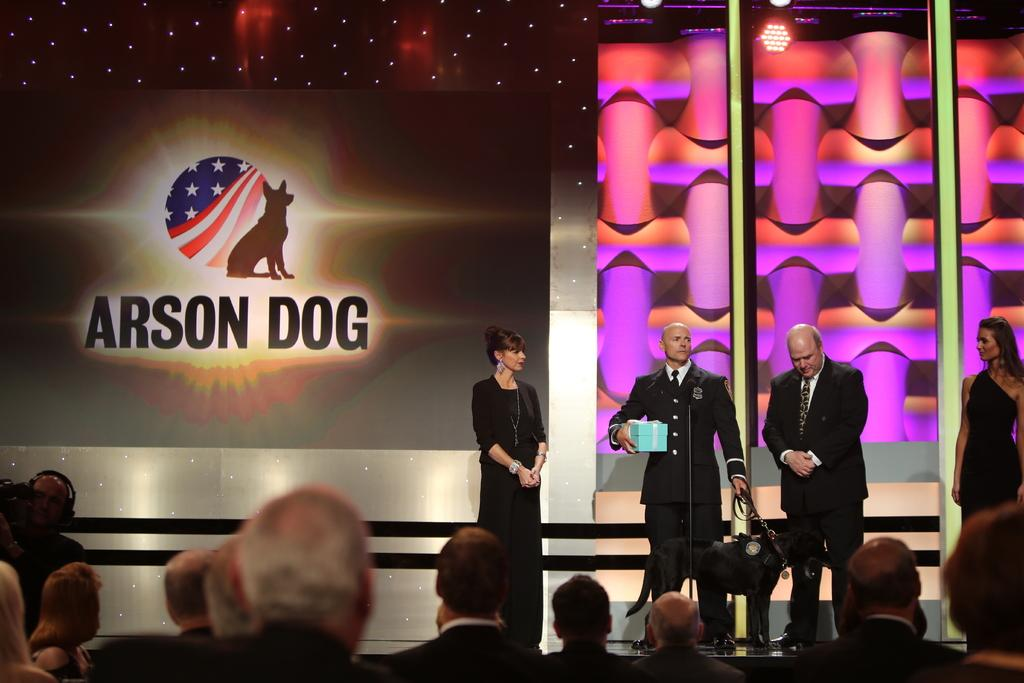<image>
Create a compact narrative representing the image presented. Four people and a dog are on stage near a screen that says Arson Dog. 